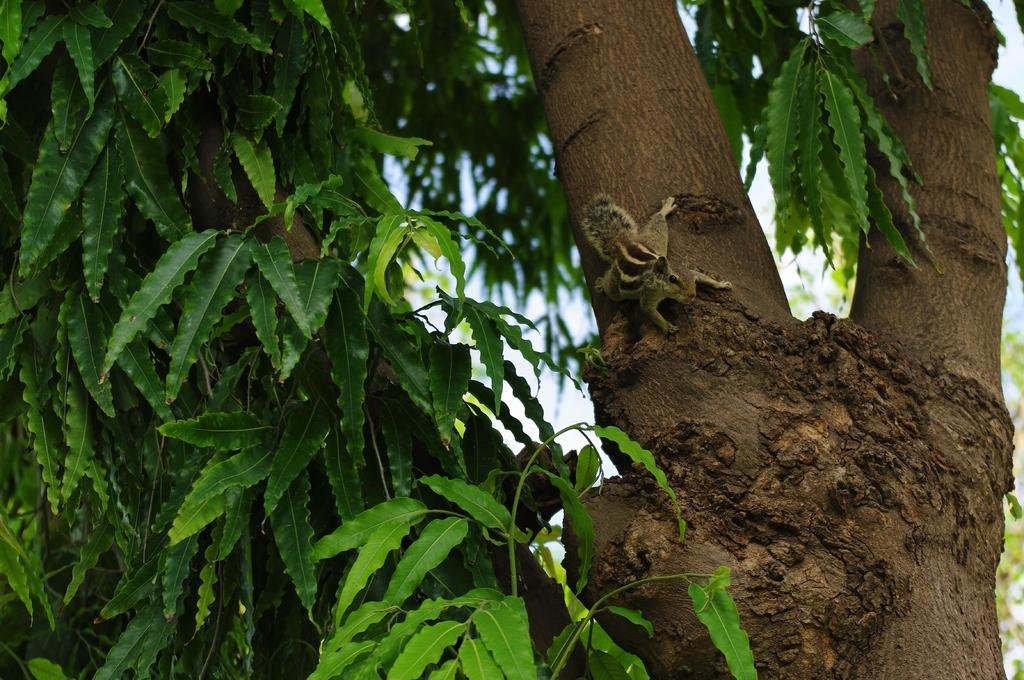What animal can be seen in the image? There is a squirrel in the image. Where is the squirrel located? The squirrel is on the branch of a tree. What type of eggs can be seen in the image? There are no eggs present in the image; it features a squirrel on a tree branch. What can be used to draw on the tree branch in the image? There is no chalk or drawing tool present in the image. 